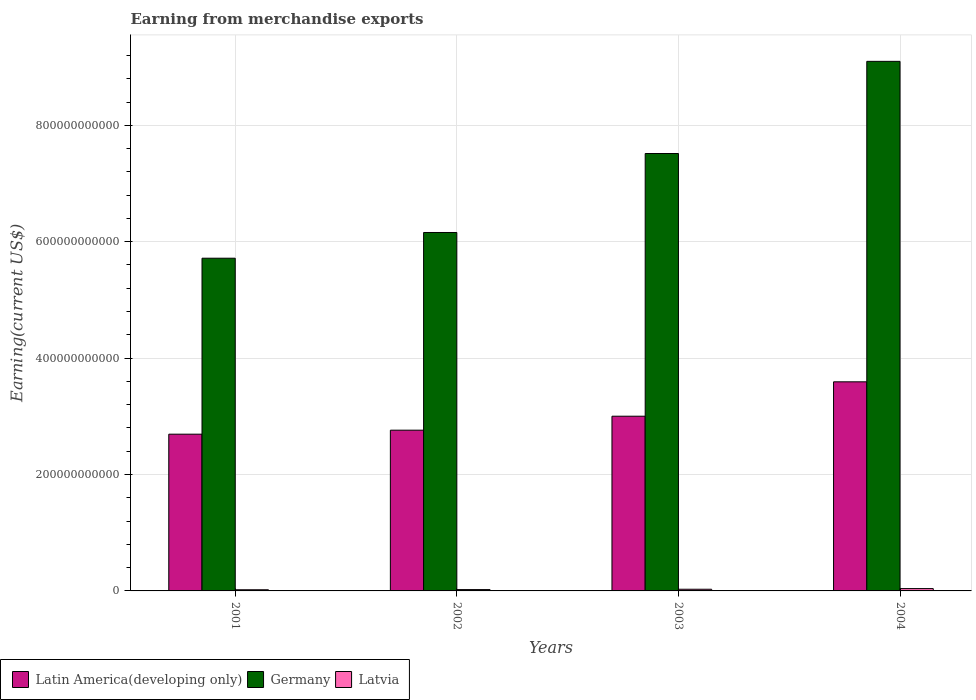Are the number of bars per tick equal to the number of legend labels?
Your response must be concise. Yes. Are the number of bars on each tick of the X-axis equal?
Your answer should be very brief. Yes. How many bars are there on the 4th tick from the right?
Your answer should be compact. 3. What is the label of the 2nd group of bars from the left?
Your answer should be compact. 2002. In how many cases, is the number of bars for a given year not equal to the number of legend labels?
Your answer should be very brief. 0. What is the amount earned from merchandise exports in Latvia in 2001?
Your response must be concise. 2.00e+09. Across all years, what is the maximum amount earned from merchandise exports in Latvia?
Keep it short and to the point. 4.01e+09. Across all years, what is the minimum amount earned from merchandise exports in Latvia?
Ensure brevity in your answer.  2.00e+09. What is the total amount earned from merchandise exports in Latin America(developing only) in the graph?
Offer a very short reply. 1.20e+12. What is the difference between the amount earned from merchandise exports in Latin America(developing only) in 2001 and that in 2003?
Make the answer very short. -3.09e+1. What is the difference between the amount earned from merchandise exports in Latin America(developing only) in 2002 and the amount earned from merchandise exports in Latvia in 2004?
Your response must be concise. 2.72e+11. What is the average amount earned from merchandise exports in Germany per year?
Offer a very short reply. 7.12e+11. In the year 2003, what is the difference between the amount earned from merchandise exports in Latvia and amount earned from merchandise exports in Latin America(developing only)?
Keep it short and to the point. -2.97e+11. In how many years, is the amount earned from merchandise exports in Germany greater than 160000000000 US$?
Keep it short and to the point. 4. What is the ratio of the amount earned from merchandise exports in Germany in 2002 to that in 2003?
Your answer should be compact. 0.82. Is the amount earned from merchandise exports in Germany in 2002 less than that in 2004?
Offer a very short reply. Yes. What is the difference between the highest and the second highest amount earned from merchandise exports in Germany?
Ensure brevity in your answer.  1.58e+11. What is the difference between the highest and the lowest amount earned from merchandise exports in Latin America(developing only)?
Your response must be concise. 9.00e+1. In how many years, is the amount earned from merchandise exports in Germany greater than the average amount earned from merchandise exports in Germany taken over all years?
Provide a short and direct response. 2. What does the 3rd bar from the left in 2004 represents?
Make the answer very short. Latvia. What does the 3rd bar from the right in 2001 represents?
Offer a terse response. Latin America(developing only). Is it the case that in every year, the sum of the amount earned from merchandise exports in Latin America(developing only) and amount earned from merchandise exports in Germany is greater than the amount earned from merchandise exports in Latvia?
Your answer should be very brief. Yes. What is the difference between two consecutive major ticks on the Y-axis?
Provide a short and direct response. 2.00e+11. Are the values on the major ticks of Y-axis written in scientific E-notation?
Make the answer very short. No. Does the graph contain any zero values?
Keep it short and to the point. No. Where does the legend appear in the graph?
Provide a succinct answer. Bottom left. How many legend labels are there?
Offer a very short reply. 3. How are the legend labels stacked?
Your response must be concise. Horizontal. What is the title of the graph?
Offer a terse response. Earning from merchandise exports. What is the label or title of the X-axis?
Your answer should be very brief. Years. What is the label or title of the Y-axis?
Give a very brief answer. Earning(current US$). What is the Earning(current US$) in Latin America(developing only) in 2001?
Offer a terse response. 2.69e+11. What is the Earning(current US$) in Germany in 2001?
Your response must be concise. 5.72e+11. What is the Earning(current US$) of Latvia in 2001?
Provide a short and direct response. 2.00e+09. What is the Earning(current US$) of Latin America(developing only) in 2002?
Offer a very short reply. 2.76e+11. What is the Earning(current US$) of Germany in 2002?
Offer a very short reply. 6.16e+11. What is the Earning(current US$) in Latvia in 2002?
Offer a very short reply. 2.29e+09. What is the Earning(current US$) of Latin America(developing only) in 2003?
Make the answer very short. 3.00e+11. What is the Earning(current US$) in Germany in 2003?
Make the answer very short. 7.52e+11. What is the Earning(current US$) of Latvia in 2003?
Provide a short and direct response. 2.89e+09. What is the Earning(current US$) of Latin America(developing only) in 2004?
Provide a succinct answer. 3.59e+11. What is the Earning(current US$) of Germany in 2004?
Provide a succinct answer. 9.10e+11. What is the Earning(current US$) in Latvia in 2004?
Make the answer very short. 4.01e+09. Across all years, what is the maximum Earning(current US$) of Latin America(developing only)?
Your response must be concise. 3.59e+11. Across all years, what is the maximum Earning(current US$) in Germany?
Make the answer very short. 9.10e+11. Across all years, what is the maximum Earning(current US$) in Latvia?
Your answer should be compact. 4.01e+09. Across all years, what is the minimum Earning(current US$) in Latin America(developing only)?
Give a very brief answer. 2.69e+11. Across all years, what is the minimum Earning(current US$) of Germany?
Offer a very short reply. 5.72e+11. Across all years, what is the minimum Earning(current US$) in Latvia?
Provide a succinct answer. 2.00e+09. What is the total Earning(current US$) of Latin America(developing only) in the graph?
Keep it short and to the point. 1.20e+12. What is the total Earning(current US$) of Germany in the graph?
Provide a succinct answer. 2.85e+12. What is the total Earning(current US$) of Latvia in the graph?
Offer a terse response. 1.12e+1. What is the difference between the Earning(current US$) of Latin America(developing only) in 2001 and that in 2002?
Keep it short and to the point. -6.86e+09. What is the difference between the Earning(current US$) of Germany in 2001 and that in 2002?
Give a very brief answer. -4.42e+1. What is the difference between the Earning(current US$) of Latvia in 2001 and that in 2002?
Offer a terse response. -2.84e+08. What is the difference between the Earning(current US$) in Latin America(developing only) in 2001 and that in 2003?
Provide a succinct answer. -3.09e+1. What is the difference between the Earning(current US$) in Germany in 2001 and that in 2003?
Your answer should be compact. -1.80e+11. What is the difference between the Earning(current US$) in Latvia in 2001 and that in 2003?
Keep it short and to the point. -8.92e+08. What is the difference between the Earning(current US$) in Latin America(developing only) in 2001 and that in 2004?
Make the answer very short. -9.00e+1. What is the difference between the Earning(current US$) in Germany in 2001 and that in 2004?
Offer a terse response. -3.38e+11. What is the difference between the Earning(current US$) in Latvia in 2001 and that in 2004?
Make the answer very short. -2.01e+09. What is the difference between the Earning(current US$) in Latin America(developing only) in 2002 and that in 2003?
Ensure brevity in your answer.  -2.40e+1. What is the difference between the Earning(current US$) of Germany in 2002 and that in 2003?
Provide a short and direct response. -1.36e+11. What is the difference between the Earning(current US$) in Latvia in 2002 and that in 2003?
Make the answer very short. -6.07e+08. What is the difference between the Earning(current US$) in Latin America(developing only) in 2002 and that in 2004?
Ensure brevity in your answer.  -8.31e+1. What is the difference between the Earning(current US$) of Germany in 2002 and that in 2004?
Give a very brief answer. -2.94e+11. What is the difference between the Earning(current US$) in Latvia in 2002 and that in 2004?
Keep it short and to the point. -1.72e+09. What is the difference between the Earning(current US$) of Latin America(developing only) in 2003 and that in 2004?
Keep it short and to the point. -5.91e+1. What is the difference between the Earning(current US$) of Germany in 2003 and that in 2004?
Provide a short and direct response. -1.58e+11. What is the difference between the Earning(current US$) in Latvia in 2003 and that in 2004?
Your answer should be very brief. -1.12e+09. What is the difference between the Earning(current US$) of Latin America(developing only) in 2001 and the Earning(current US$) of Germany in 2002?
Offer a very short reply. -3.47e+11. What is the difference between the Earning(current US$) of Latin America(developing only) in 2001 and the Earning(current US$) of Latvia in 2002?
Your response must be concise. 2.67e+11. What is the difference between the Earning(current US$) in Germany in 2001 and the Earning(current US$) in Latvia in 2002?
Provide a short and direct response. 5.69e+11. What is the difference between the Earning(current US$) of Latin America(developing only) in 2001 and the Earning(current US$) of Germany in 2003?
Your answer should be very brief. -4.82e+11. What is the difference between the Earning(current US$) of Latin America(developing only) in 2001 and the Earning(current US$) of Latvia in 2003?
Your response must be concise. 2.66e+11. What is the difference between the Earning(current US$) in Germany in 2001 and the Earning(current US$) in Latvia in 2003?
Ensure brevity in your answer.  5.69e+11. What is the difference between the Earning(current US$) in Latin America(developing only) in 2001 and the Earning(current US$) in Germany in 2004?
Offer a terse response. -6.41e+11. What is the difference between the Earning(current US$) in Latin America(developing only) in 2001 and the Earning(current US$) in Latvia in 2004?
Your answer should be compact. 2.65e+11. What is the difference between the Earning(current US$) in Germany in 2001 and the Earning(current US$) in Latvia in 2004?
Ensure brevity in your answer.  5.68e+11. What is the difference between the Earning(current US$) of Latin America(developing only) in 2002 and the Earning(current US$) of Germany in 2003?
Ensure brevity in your answer.  -4.75e+11. What is the difference between the Earning(current US$) of Latin America(developing only) in 2002 and the Earning(current US$) of Latvia in 2003?
Make the answer very short. 2.73e+11. What is the difference between the Earning(current US$) of Germany in 2002 and the Earning(current US$) of Latvia in 2003?
Give a very brief answer. 6.13e+11. What is the difference between the Earning(current US$) of Latin America(developing only) in 2002 and the Earning(current US$) of Germany in 2004?
Offer a very short reply. -6.34e+11. What is the difference between the Earning(current US$) of Latin America(developing only) in 2002 and the Earning(current US$) of Latvia in 2004?
Make the answer very short. 2.72e+11. What is the difference between the Earning(current US$) in Germany in 2002 and the Earning(current US$) in Latvia in 2004?
Make the answer very short. 6.12e+11. What is the difference between the Earning(current US$) of Latin America(developing only) in 2003 and the Earning(current US$) of Germany in 2004?
Make the answer very short. -6.10e+11. What is the difference between the Earning(current US$) in Latin America(developing only) in 2003 and the Earning(current US$) in Latvia in 2004?
Make the answer very short. 2.96e+11. What is the difference between the Earning(current US$) of Germany in 2003 and the Earning(current US$) of Latvia in 2004?
Your answer should be very brief. 7.48e+11. What is the average Earning(current US$) of Latin America(developing only) per year?
Keep it short and to the point. 3.01e+11. What is the average Earning(current US$) in Germany per year?
Provide a succinct answer. 7.12e+11. What is the average Earning(current US$) of Latvia per year?
Make the answer very short. 2.80e+09. In the year 2001, what is the difference between the Earning(current US$) of Latin America(developing only) and Earning(current US$) of Germany?
Your answer should be very brief. -3.02e+11. In the year 2001, what is the difference between the Earning(current US$) in Latin America(developing only) and Earning(current US$) in Latvia?
Make the answer very short. 2.67e+11. In the year 2001, what is the difference between the Earning(current US$) of Germany and Earning(current US$) of Latvia?
Make the answer very short. 5.70e+11. In the year 2002, what is the difference between the Earning(current US$) in Latin America(developing only) and Earning(current US$) in Germany?
Keep it short and to the point. -3.40e+11. In the year 2002, what is the difference between the Earning(current US$) in Latin America(developing only) and Earning(current US$) in Latvia?
Ensure brevity in your answer.  2.74e+11. In the year 2002, what is the difference between the Earning(current US$) in Germany and Earning(current US$) in Latvia?
Provide a short and direct response. 6.14e+11. In the year 2003, what is the difference between the Earning(current US$) in Latin America(developing only) and Earning(current US$) in Germany?
Provide a short and direct response. -4.51e+11. In the year 2003, what is the difference between the Earning(current US$) in Latin America(developing only) and Earning(current US$) in Latvia?
Keep it short and to the point. 2.97e+11. In the year 2003, what is the difference between the Earning(current US$) in Germany and Earning(current US$) in Latvia?
Give a very brief answer. 7.49e+11. In the year 2004, what is the difference between the Earning(current US$) in Latin America(developing only) and Earning(current US$) in Germany?
Offer a terse response. -5.51e+11. In the year 2004, what is the difference between the Earning(current US$) of Latin America(developing only) and Earning(current US$) of Latvia?
Provide a succinct answer. 3.55e+11. In the year 2004, what is the difference between the Earning(current US$) in Germany and Earning(current US$) in Latvia?
Provide a succinct answer. 9.06e+11. What is the ratio of the Earning(current US$) of Latin America(developing only) in 2001 to that in 2002?
Offer a terse response. 0.98. What is the ratio of the Earning(current US$) of Germany in 2001 to that in 2002?
Give a very brief answer. 0.93. What is the ratio of the Earning(current US$) of Latvia in 2001 to that in 2002?
Your answer should be compact. 0.88. What is the ratio of the Earning(current US$) of Latin America(developing only) in 2001 to that in 2003?
Your answer should be very brief. 0.9. What is the ratio of the Earning(current US$) of Germany in 2001 to that in 2003?
Your response must be concise. 0.76. What is the ratio of the Earning(current US$) in Latvia in 2001 to that in 2003?
Provide a succinct answer. 0.69. What is the ratio of the Earning(current US$) in Latin America(developing only) in 2001 to that in 2004?
Your response must be concise. 0.75. What is the ratio of the Earning(current US$) in Germany in 2001 to that in 2004?
Give a very brief answer. 0.63. What is the ratio of the Earning(current US$) in Latvia in 2001 to that in 2004?
Offer a very short reply. 0.5. What is the ratio of the Earning(current US$) in Latin America(developing only) in 2002 to that in 2003?
Provide a short and direct response. 0.92. What is the ratio of the Earning(current US$) in Germany in 2002 to that in 2003?
Provide a short and direct response. 0.82. What is the ratio of the Earning(current US$) in Latvia in 2002 to that in 2003?
Ensure brevity in your answer.  0.79. What is the ratio of the Earning(current US$) in Latin America(developing only) in 2002 to that in 2004?
Keep it short and to the point. 0.77. What is the ratio of the Earning(current US$) in Germany in 2002 to that in 2004?
Provide a succinct answer. 0.68. What is the ratio of the Earning(current US$) in Latvia in 2002 to that in 2004?
Provide a short and direct response. 0.57. What is the ratio of the Earning(current US$) in Latin America(developing only) in 2003 to that in 2004?
Your answer should be very brief. 0.84. What is the ratio of the Earning(current US$) of Germany in 2003 to that in 2004?
Your response must be concise. 0.83. What is the ratio of the Earning(current US$) of Latvia in 2003 to that in 2004?
Your answer should be compact. 0.72. What is the difference between the highest and the second highest Earning(current US$) of Latin America(developing only)?
Your response must be concise. 5.91e+1. What is the difference between the highest and the second highest Earning(current US$) of Germany?
Keep it short and to the point. 1.58e+11. What is the difference between the highest and the second highest Earning(current US$) in Latvia?
Your answer should be very brief. 1.12e+09. What is the difference between the highest and the lowest Earning(current US$) in Latin America(developing only)?
Offer a terse response. 9.00e+1. What is the difference between the highest and the lowest Earning(current US$) of Germany?
Your response must be concise. 3.38e+11. What is the difference between the highest and the lowest Earning(current US$) of Latvia?
Make the answer very short. 2.01e+09. 